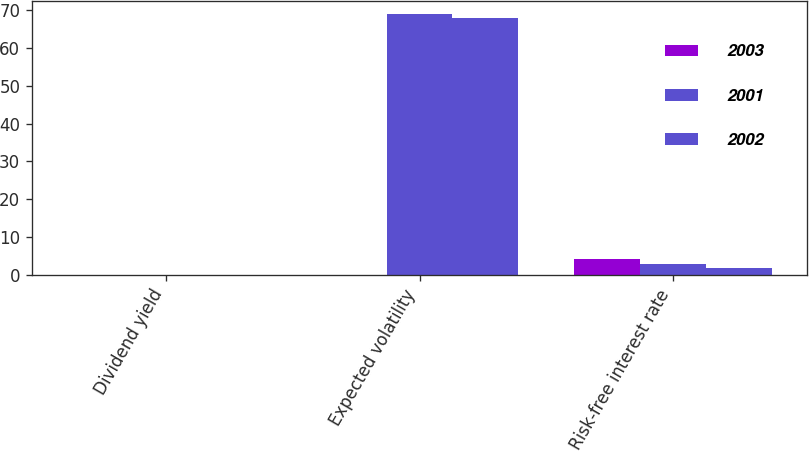Convert chart to OTSL. <chart><loc_0><loc_0><loc_500><loc_500><stacked_bar_chart><ecel><fcel>Dividend yield<fcel>Expected volatility<fcel>Risk-free interest rate<nl><fcel>2003<fcel>0<fcel>0<fcel>4.14<nl><fcel>2001<fcel>0<fcel>69<fcel>2.79<nl><fcel>2002<fcel>0<fcel>68<fcel>1.81<nl></chart> 